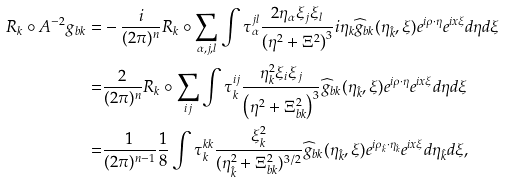Convert formula to latex. <formula><loc_0><loc_0><loc_500><loc_500>R _ { k } \circ A ^ { - 2 } g _ { b k } = & - \frac { i } { ( 2 \pi ) ^ { n } } R _ { k } \circ \sum _ { \alpha , j , l } \int \tau _ { \alpha } ^ { j l } \frac { 2 \eta _ { \alpha } \xi _ { j } \xi _ { l } } { \left ( \eta ^ { 2 } + \Xi ^ { 2 } \right ) ^ { 3 } } i \eta _ { k } \widehat { g } _ { b k } ( \eta _ { \hat { k } } , \xi ) e ^ { i \rho \cdot \eta } e ^ { i x \xi } d \eta d \xi \\ = & \frac { 2 } { ( 2 \pi ) ^ { n } } R _ { k } \circ \sum _ { i j } \int \tau _ { k } ^ { i j } \frac { \eta _ { k } ^ { 2 } \xi _ { i } \xi _ { j } } { \left ( \eta ^ { 2 } + \Xi ^ { 2 } _ { b k } \right ) ^ { 3 } } \widehat { g } _ { b k } ( \eta _ { \hat { k } } , \xi ) e ^ { i \rho \cdot \eta } e ^ { i x \xi } d \eta d \xi \\ = & \frac { 1 } { ( 2 \pi ) ^ { n - 1 } } \frac { 1 } { 8 } \int \tau _ { k } ^ { k k } \frac { \xi _ { k } ^ { 2 } } { ( \eta _ { \hat { k } } ^ { 2 } + \Xi _ { b k } ^ { 2 } ) ^ { 3 / 2 } } \widehat { g } _ { b k } ( \eta _ { \hat { k } } , \xi ) e ^ { i \rho _ { \hat { k } } \cdot \eta _ { \hat { k } } } e ^ { i x \xi } d \eta _ { \hat { k } } d \xi ,</formula> 